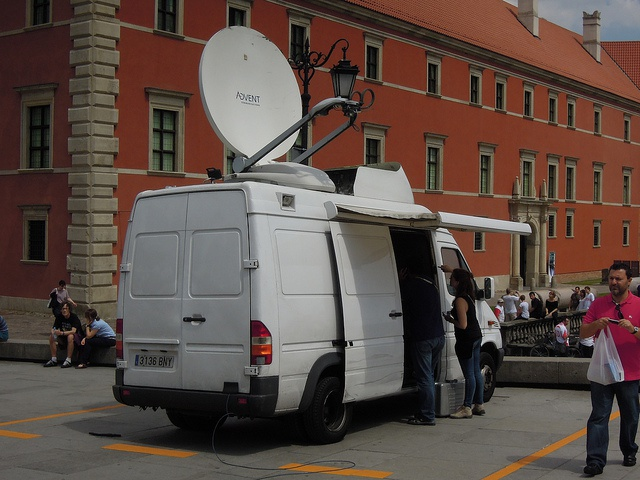Describe the objects in this image and their specific colors. I can see truck in black, darkgray, and gray tones, bus in black, gray, and darkgray tones, people in black, maroon, gray, and brown tones, people in black and gray tones, and people in black, gray, and maroon tones in this image. 